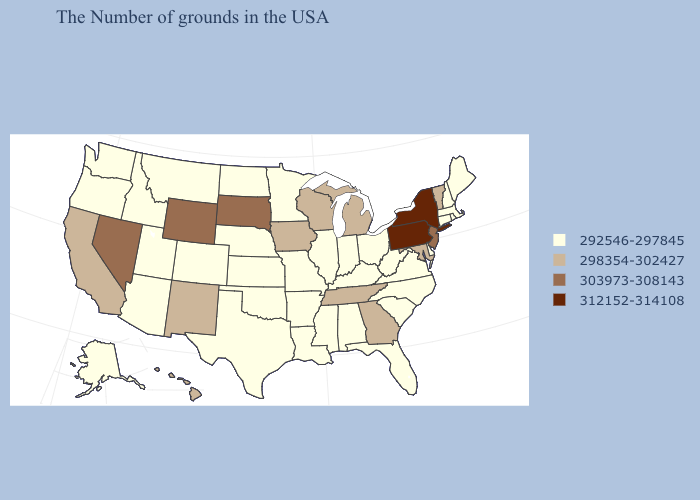Which states hav the highest value in the West?
Give a very brief answer. Wyoming, Nevada. Among the states that border Michigan , does Wisconsin have the highest value?
Write a very short answer. Yes. Among the states that border Rhode Island , which have the highest value?
Answer briefly. Massachusetts, Connecticut. Does the first symbol in the legend represent the smallest category?
Write a very short answer. Yes. What is the value of Nebraska?
Concise answer only. 292546-297845. Name the states that have a value in the range 298354-302427?
Quick response, please. Vermont, Maryland, Georgia, Michigan, Tennessee, Wisconsin, Iowa, New Mexico, California, Hawaii. What is the value of Kentucky?
Be succinct. 292546-297845. Does Oregon have the lowest value in the West?
Be succinct. Yes. Among the states that border Missouri , which have the highest value?
Answer briefly. Tennessee, Iowa. Which states have the highest value in the USA?
Give a very brief answer. New York, Pennsylvania. What is the value of North Carolina?
Keep it brief. 292546-297845. Does Montana have the lowest value in the West?
Be succinct. Yes. Does Wisconsin have a lower value than Wyoming?
Short answer required. Yes. Among the states that border Georgia , which have the lowest value?
Answer briefly. North Carolina, South Carolina, Florida, Alabama. What is the lowest value in states that border Kentucky?
Short answer required. 292546-297845. 